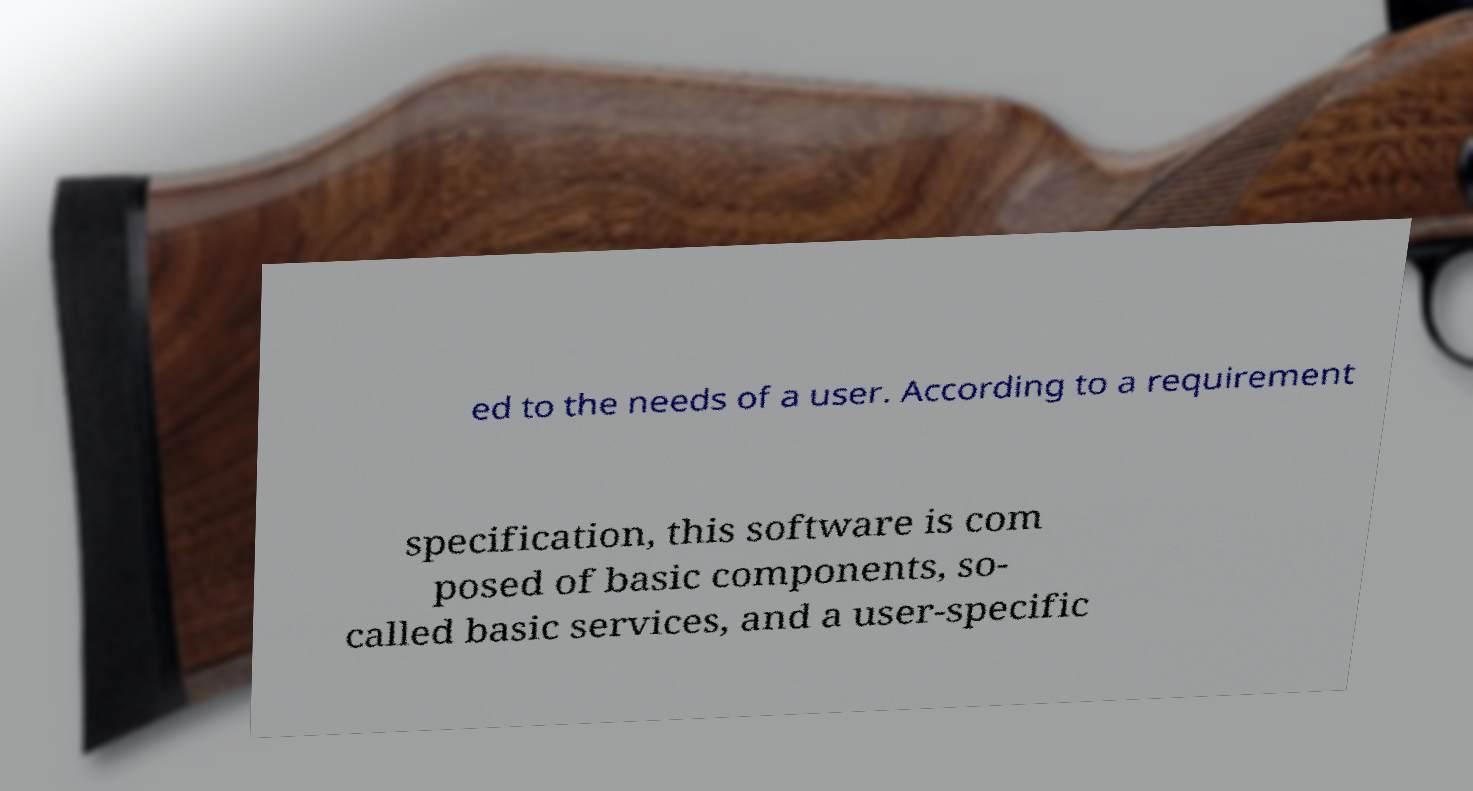Could you assist in decoding the text presented in this image and type it out clearly? ed to the needs of a user. According to a requirement specification, this software is com posed of basic components, so- called basic services, and a user-specific 